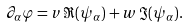<formula> <loc_0><loc_0><loc_500><loc_500>\partial _ { \alpha } \varphi = v \, \Re ( \psi _ { \alpha } ) + w \, \Im ( \psi _ { \alpha } ) .</formula> 